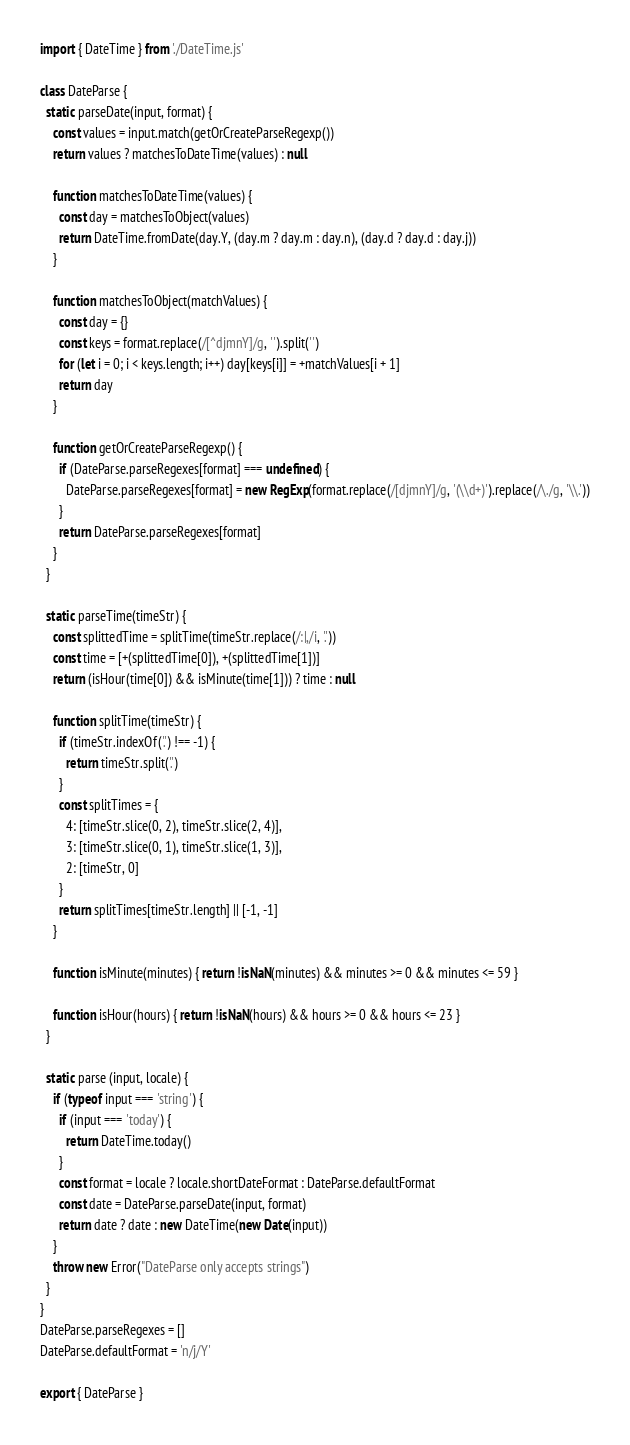<code> <loc_0><loc_0><loc_500><loc_500><_JavaScript_>import { DateTime } from './DateTime.js'

class DateParse {
  static parseDate(input, format) {
    const values = input.match(getOrCreateParseRegexp())
    return values ? matchesToDateTime(values) : null

    function matchesToDateTime(values) {
      const day = matchesToObject(values)
      return DateTime.fromDate(day.Y, (day.m ? day.m : day.n), (day.d ? day.d : day.j))
    }

    function matchesToObject(matchValues) {
      const day = {}
      const keys = format.replace(/[^djmnY]/g, '').split('')
      for (let i = 0; i < keys.length; i++) day[keys[i]] = +matchValues[i + 1]
      return day
    }

    function getOrCreateParseRegexp() {
      if (DateParse.parseRegexes[format] === undefined) {
        DateParse.parseRegexes[format] = new RegExp(format.replace(/[djmnY]/g, '(\\d+)').replace(/\./g, '\\.'))
      }
      return DateParse.parseRegexes[format]
    }
  }

  static parseTime(timeStr) {
    const splittedTime = splitTime(timeStr.replace(/:|,/i, '.'))
    const time = [+(splittedTime[0]), +(splittedTime[1])]
    return (isHour(time[0]) && isMinute(time[1])) ? time : null

    function splitTime(timeStr) {
      if (timeStr.indexOf('.') !== -1) {
        return timeStr.split('.')
      }
      const splitTimes = {
        4: [timeStr.slice(0, 2), timeStr.slice(2, 4)],
        3: [timeStr.slice(0, 1), timeStr.slice(1, 3)],
        2: [timeStr, 0]
      }
      return splitTimes[timeStr.length] || [-1, -1]
    }

    function isMinute(minutes) { return !isNaN(minutes) && minutes >= 0 && minutes <= 59 }

    function isHour(hours) { return !isNaN(hours) && hours >= 0 && hours <= 23 }
  }

  static parse (input, locale) {
    if (typeof input === 'string') {
      if (input === 'today') {
        return DateTime.today()
      }
      const format = locale ? locale.shortDateFormat : DateParse.defaultFormat
      const date = DateParse.parseDate(input, format)
      return date ? date : new DateTime(new Date(input))
    }
    throw new Error("DateParse only accepts strings")
  }
}
DateParse.parseRegexes = []
DateParse.defaultFormat = 'n/j/Y'

export { DateParse }
</code> 